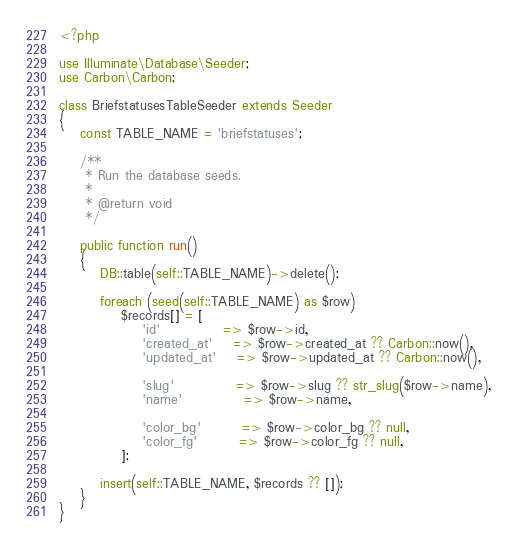Convert code to text. <code><loc_0><loc_0><loc_500><loc_500><_PHP_><?php

use Illuminate\Database\Seeder;
use Carbon\Carbon;

class BriefstatusesTableSeeder extends Seeder
{
	const TABLE_NAME = 'briefstatuses';

	/**
	 * Run the database seeds.
	 *
	 * @return void
	 */

	public function run()
	{
		DB::table(self::TABLE_NAME)->delete();

		foreach (seed(self::TABLE_NAME) as $row)
			$records[] = [
				'id'			=> $row->id,
				'created_at'	=> $row->created_at ?? Carbon::now(),
				'updated_at'	=> $row->updated_at ?? Carbon::now(),

				'slug'			=> $row->slug ?? str_slug($row->name),
				'name'			=> $row->name,

				'color_bg'		=> $row->color_bg ?? null,
				'color_fg'		=> $row->color_fg ?? null,
			];

		insert(self::TABLE_NAME, $records ?? []);
	}
}
</code> 